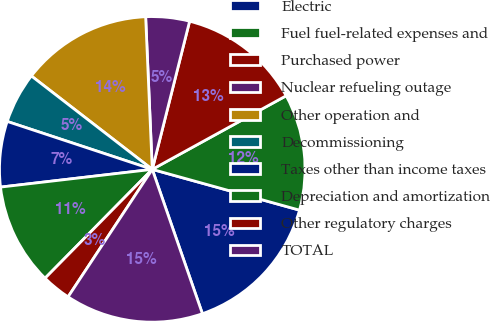Convert chart. <chart><loc_0><loc_0><loc_500><loc_500><pie_chart><fcel>Electric<fcel>Fuel fuel-related expenses and<fcel>Purchased power<fcel>Nuclear refueling outage<fcel>Other operation and<fcel>Decommissioning<fcel>Taxes other than income taxes<fcel>Depreciation and amortization<fcel>Other regulatory charges<fcel>TOTAL<nl><fcel>15.38%<fcel>12.3%<fcel>13.07%<fcel>4.62%<fcel>13.84%<fcel>5.39%<fcel>6.93%<fcel>10.77%<fcel>3.09%<fcel>14.61%<nl></chart> 